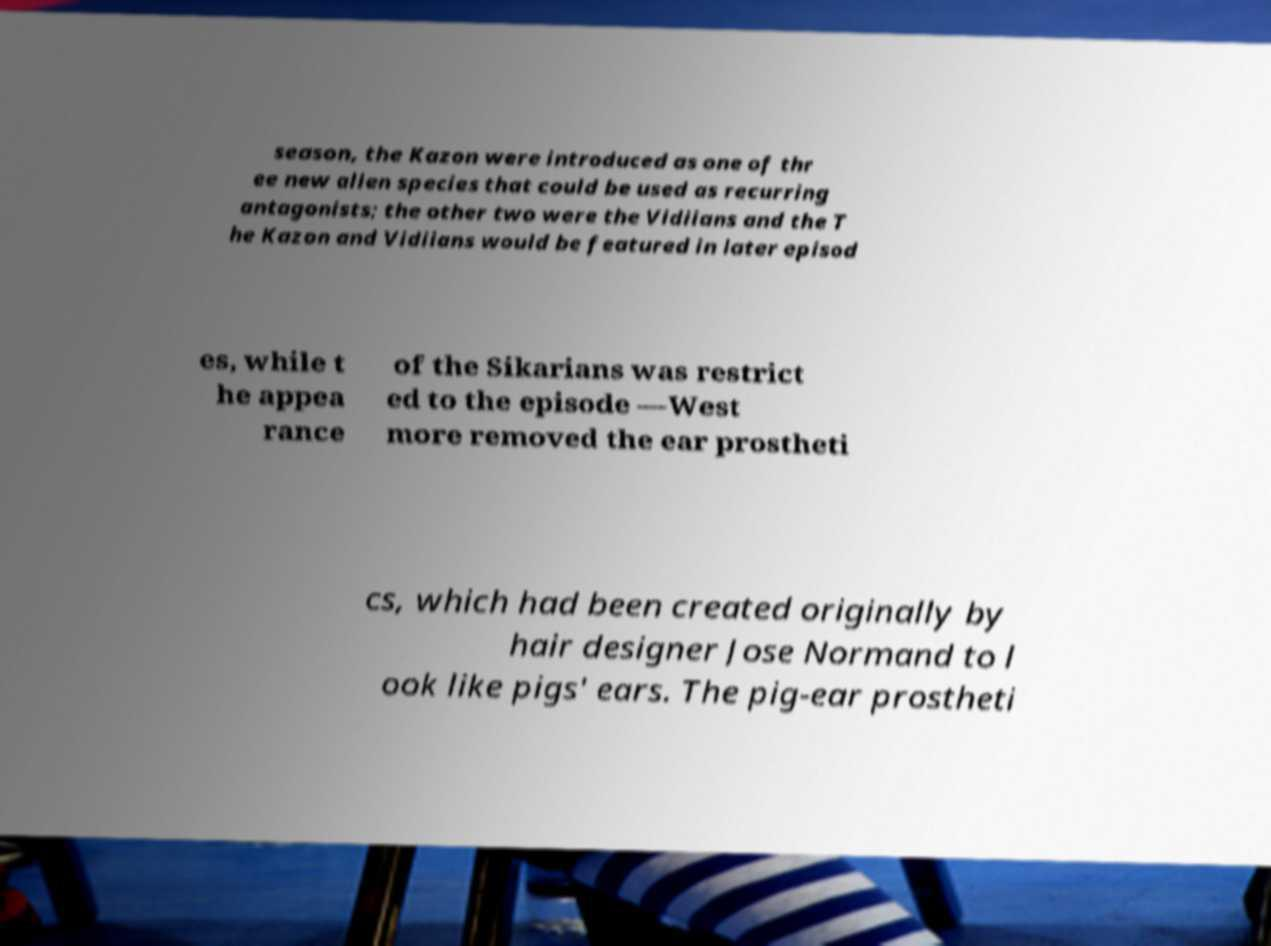Could you assist in decoding the text presented in this image and type it out clearly? season, the Kazon were introduced as one of thr ee new alien species that could be used as recurring antagonists; the other two were the Vidiians and the T he Kazon and Vidiians would be featured in later episod es, while t he appea rance of the Sikarians was restrict ed to the episode —West more removed the ear prostheti cs, which had been created originally by hair designer Jose Normand to l ook like pigs' ears. The pig-ear prostheti 